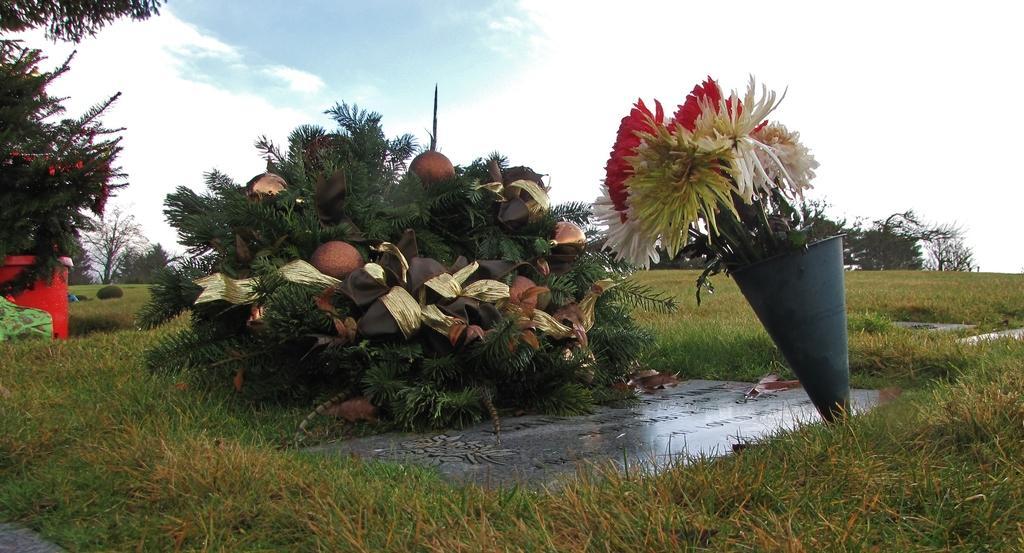How would you summarize this image in a sentence or two? In the picture I can see flowers, the grass, plants, trees and some other objects on the ground. In the background I can see the sky. 